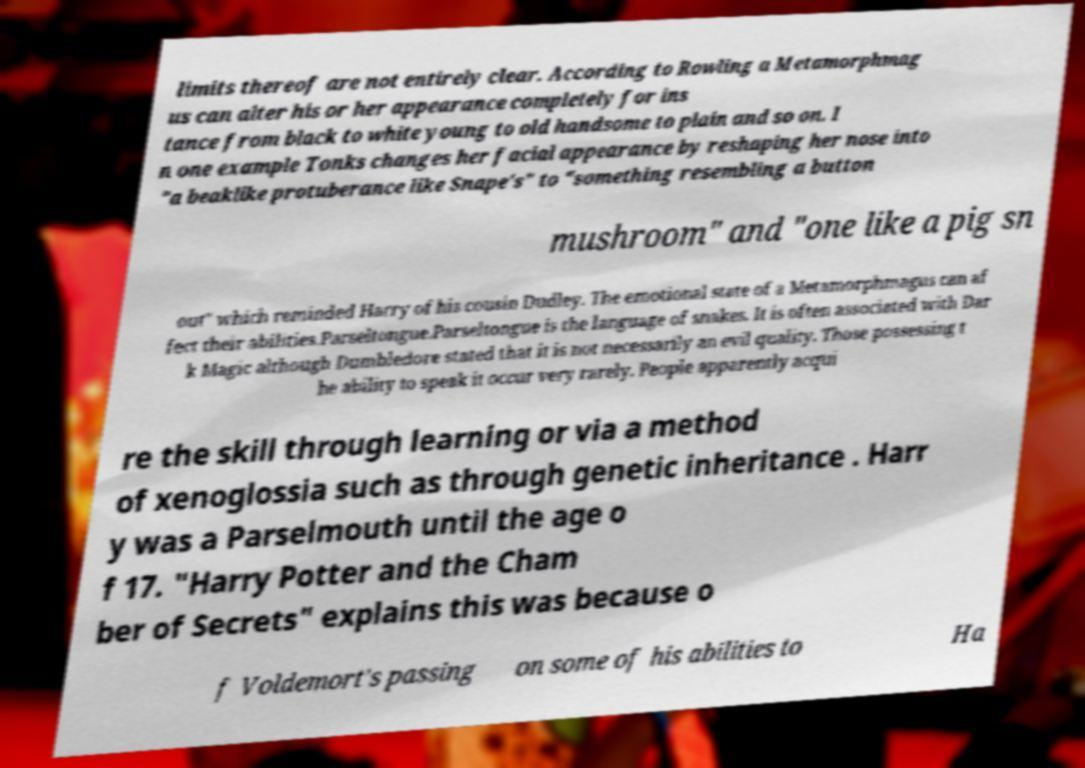What messages or text are displayed in this image? I need them in a readable, typed format. limits thereof are not entirely clear. According to Rowling a Metamorphmag us can alter his or her appearance completely for ins tance from black to white young to old handsome to plain and so on. I n one example Tonks changes her facial appearance by reshaping her nose into "a beaklike protuberance like Snape's" to "something resembling a button mushroom" and "one like a pig sn out" which reminded Harry of his cousin Dudley. The emotional state of a Metamorphmagus can af fect their abilities.Parseltongue.Parseltongue is the language of snakes. It is often associated with Dar k Magic although Dumbledore stated that it is not necessarily an evil quality. Those possessing t he ability to speak it occur very rarely. People apparently acqui re the skill through learning or via a method of xenoglossia such as through genetic inheritance . Harr y was a Parselmouth until the age o f 17. "Harry Potter and the Cham ber of Secrets" explains this was because o f Voldemort's passing on some of his abilities to Ha 